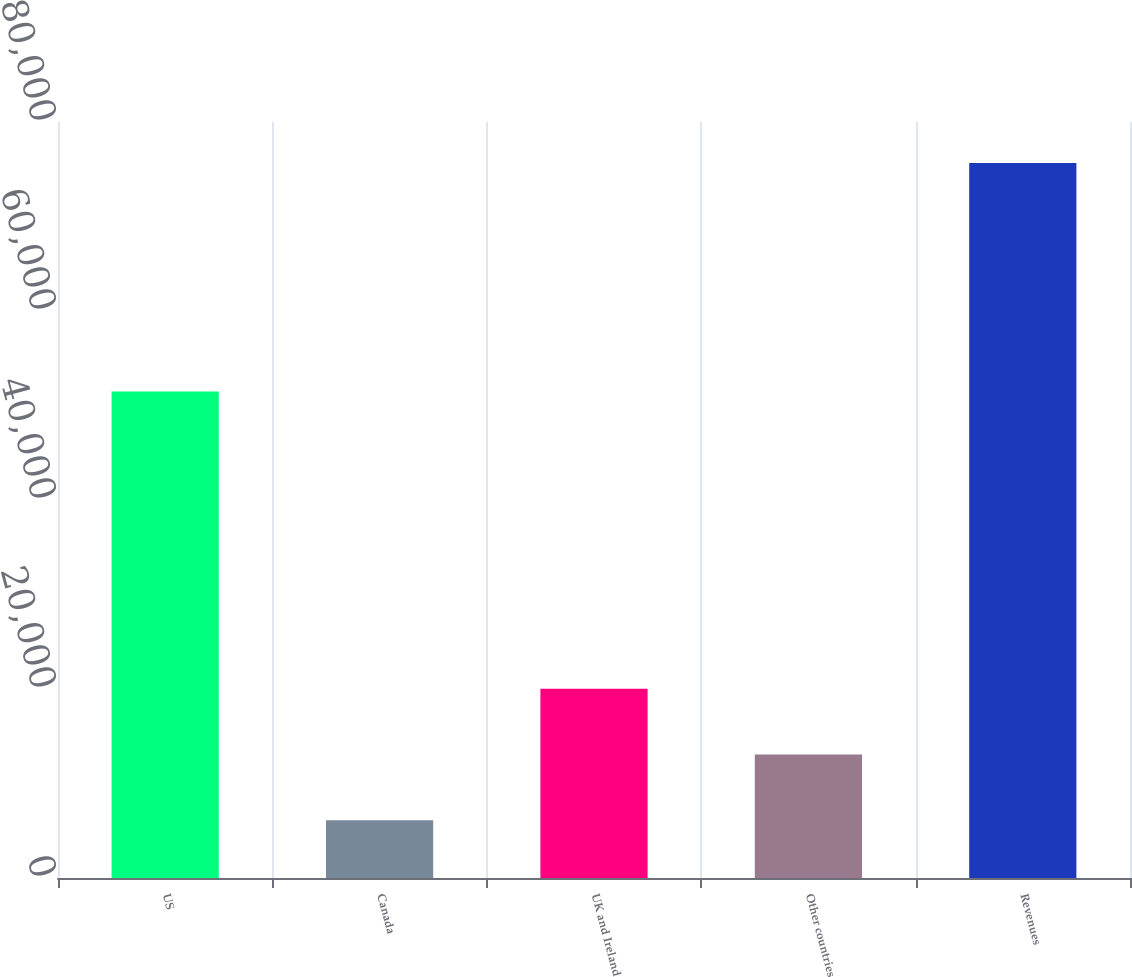<chart> <loc_0><loc_0><loc_500><loc_500><bar_chart><fcel>US<fcel>Canada<fcel>UK and Ireland<fcel>Other countries<fcel>Revenues<nl><fcel>51479<fcel>6115<fcel>20023.8<fcel>13069.4<fcel>75659<nl></chart> 